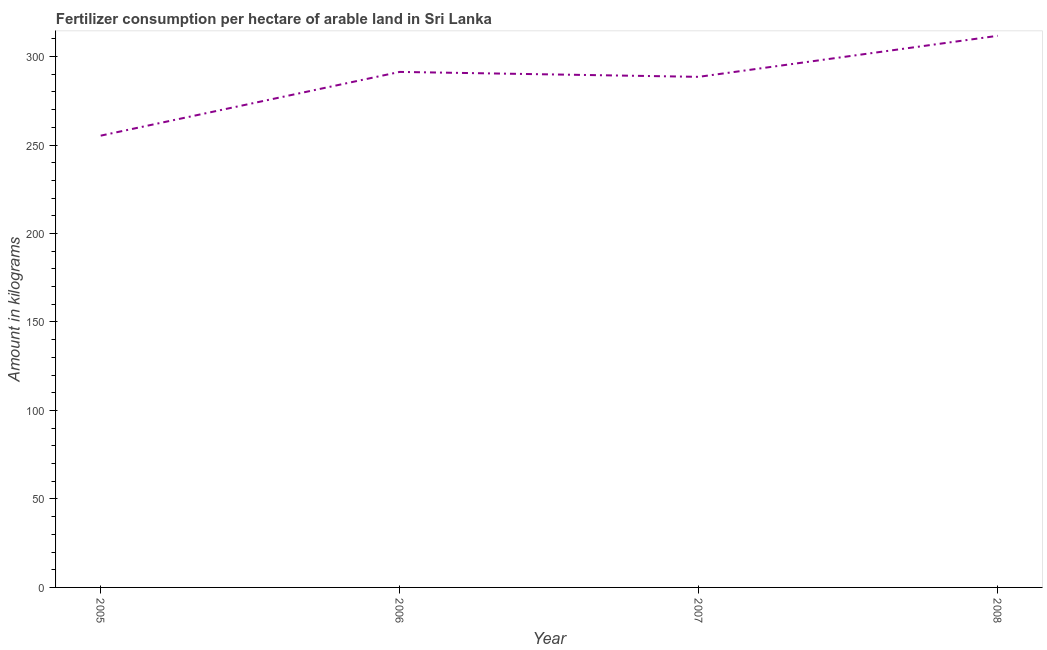What is the amount of fertilizer consumption in 2008?
Your answer should be very brief. 311.71. Across all years, what is the maximum amount of fertilizer consumption?
Give a very brief answer. 311.71. Across all years, what is the minimum amount of fertilizer consumption?
Offer a terse response. 255.29. In which year was the amount of fertilizer consumption minimum?
Provide a short and direct response. 2005. What is the sum of the amount of fertilizer consumption?
Your answer should be compact. 1146.84. What is the difference between the amount of fertilizer consumption in 2005 and 2006?
Make the answer very short. -36.02. What is the average amount of fertilizer consumption per year?
Ensure brevity in your answer.  286.71. What is the median amount of fertilizer consumption?
Make the answer very short. 289.92. What is the ratio of the amount of fertilizer consumption in 2006 to that in 2007?
Make the answer very short. 1.01. Is the amount of fertilizer consumption in 2006 less than that in 2007?
Provide a succinct answer. No. Is the difference between the amount of fertilizer consumption in 2007 and 2008 greater than the difference between any two years?
Your response must be concise. No. What is the difference between the highest and the second highest amount of fertilizer consumption?
Your answer should be compact. 20.4. Is the sum of the amount of fertilizer consumption in 2005 and 2008 greater than the maximum amount of fertilizer consumption across all years?
Offer a very short reply. Yes. What is the difference between the highest and the lowest amount of fertilizer consumption?
Your response must be concise. 56.42. In how many years, is the amount of fertilizer consumption greater than the average amount of fertilizer consumption taken over all years?
Provide a succinct answer. 3. Does the amount of fertilizer consumption monotonically increase over the years?
Your response must be concise. No. Are the values on the major ticks of Y-axis written in scientific E-notation?
Give a very brief answer. No. Does the graph contain grids?
Ensure brevity in your answer.  No. What is the title of the graph?
Provide a short and direct response. Fertilizer consumption per hectare of arable land in Sri Lanka . What is the label or title of the X-axis?
Your answer should be compact. Year. What is the label or title of the Y-axis?
Provide a short and direct response. Amount in kilograms. What is the Amount in kilograms of 2005?
Your response must be concise. 255.29. What is the Amount in kilograms of 2006?
Offer a very short reply. 291.32. What is the Amount in kilograms of 2007?
Ensure brevity in your answer.  288.52. What is the Amount in kilograms of 2008?
Provide a succinct answer. 311.71. What is the difference between the Amount in kilograms in 2005 and 2006?
Offer a very short reply. -36.02. What is the difference between the Amount in kilograms in 2005 and 2007?
Your response must be concise. -33.23. What is the difference between the Amount in kilograms in 2005 and 2008?
Give a very brief answer. -56.42. What is the difference between the Amount in kilograms in 2006 and 2007?
Your response must be concise. 2.79. What is the difference between the Amount in kilograms in 2006 and 2008?
Offer a terse response. -20.4. What is the difference between the Amount in kilograms in 2007 and 2008?
Provide a short and direct response. -23.19. What is the ratio of the Amount in kilograms in 2005 to that in 2006?
Offer a very short reply. 0.88. What is the ratio of the Amount in kilograms in 2005 to that in 2007?
Provide a short and direct response. 0.89. What is the ratio of the Amount in kilograms in 2005 to that in 2008?
Your answer should be very brief. 0.82. What is the ratio of the Amount in kilograms in 2006 to that in 2008?
Give a very brief answer. 0.94. What is the ratio of the Amount in kilograms in 2007 to that in 2008?
Provide a succinct answer. 0.93. 